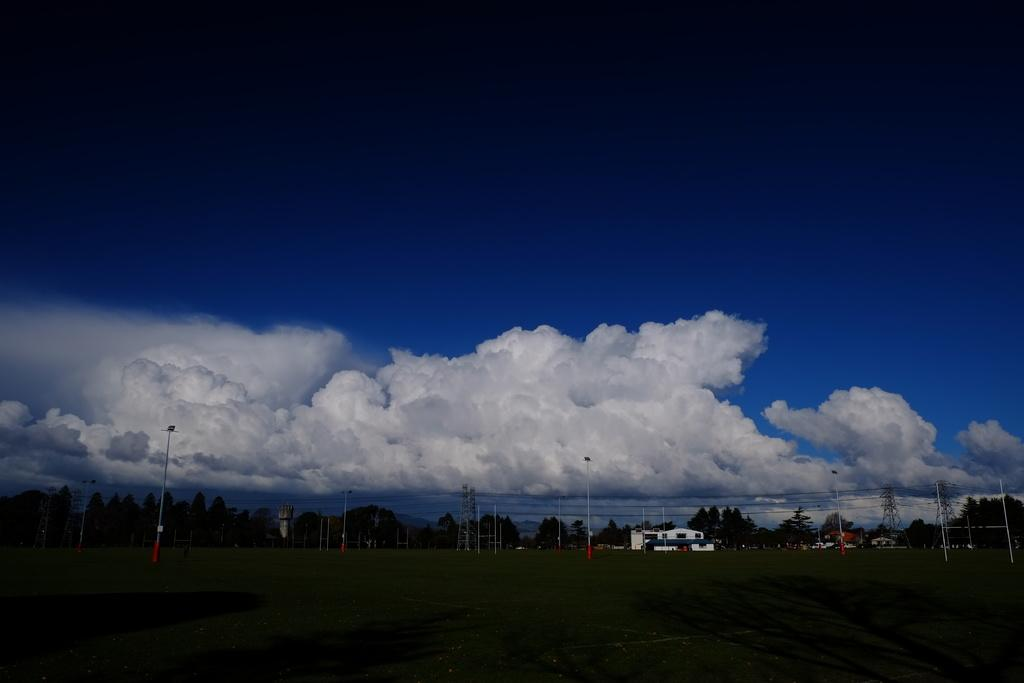What can be seen in the sky in the image? The sky with clouds is visible in the image. What structures are present in the image? Poles, an overhead tank, buildings, and trees are visible in the image. What is connected to the poles in the image? Cables are visible in the image, connecting to the poles. What is the ground like in the image? The ground is visible in the image. What type of apparel is the girl wearing in the image? There is no girl present in the image, so it is not possible to answer that question. 